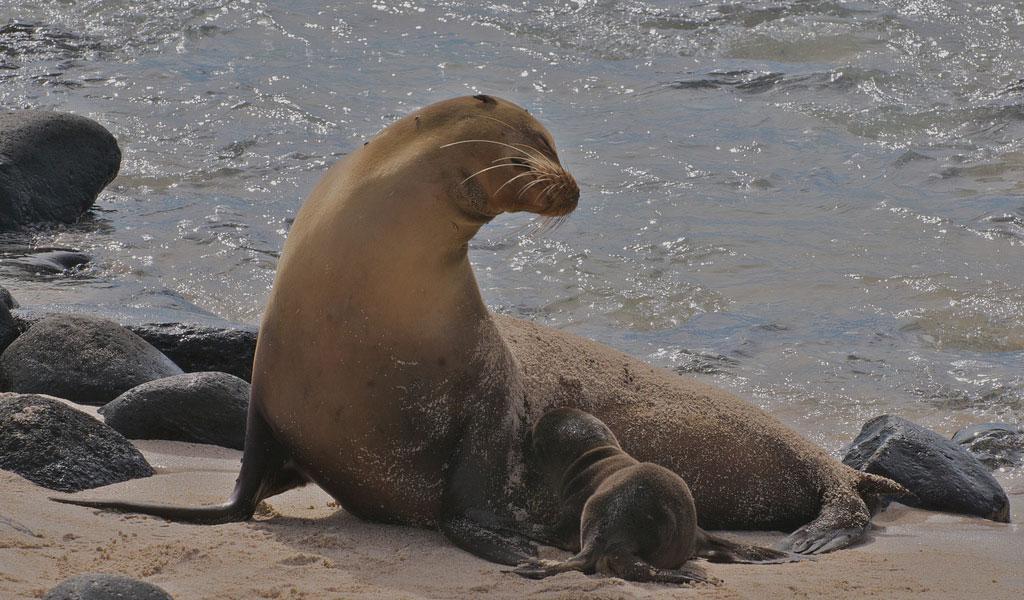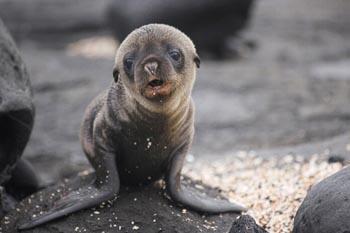The first image is the image on the left, the second image is the image on the right. Analyze the images presented: Is the assertion "A single seal is standing on top of a rock with its mouth open." valid? Answer yes or no. Yes. The first image is the image on the left, the second image is the image on the right. Evaluate the accuracy of this statement regarding the images: "One seal has its mouth open, and another one does not.". Is it true? Answer yes or no. Yes. 